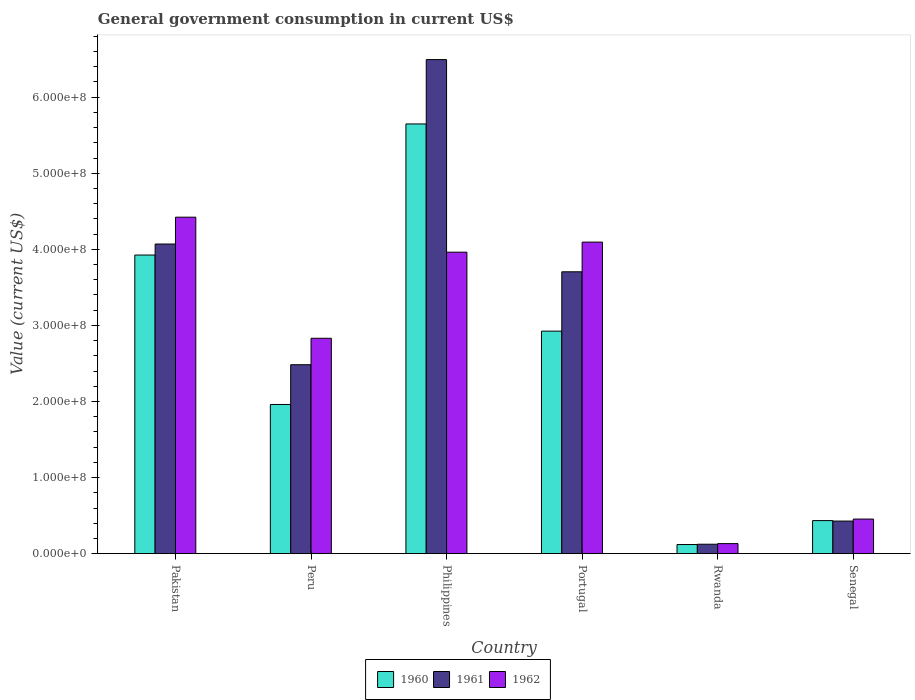How many different coloured bars are there?
Keep it short and to the point. 3. Are the number of bars per tick equal to the number of legend labels?
Offer a terse response. Yes. How many bars are there on the 6th tick from the left?
Provide a short and direct response. 3. How many bars are there on the 3rd tick from the right?
Ensure brevity in your answer.  3. What is the government conusmption in 1962 in Philippines?
Your response must be concise. 3.96e+08. Across all countries, what is the maximum government conusmption in 1962?
Your answer should be very brief. 4.42e+08. Across all countries, what is the minimum government conusmption in 1960?
Ensure brevity in your answer.  1.20e+07. In which country was the government conusmption in 1962 maximum?
Your answer should be very brief. Pakistan. In which country was the government conusmption in 1960 minimum?
Give a very brief answer. Rwanda. What is the total government conusmption in 1961 in the graph?
Your answer should be very brief. 1.73e+09. What is the difference between the government conusmption in 1962 in Pakistan and that in Senegal?
Give a very brief answer. 3.97e+08. What is the difference between the government conusmption in 1960 in Philippines and the government conusmption in 1961 in Portugal?
Keep it short and to the point. 1.94e+08. What is the average government conusmption in 1960 per country?
Your answer should be compact. 2.50e+08. What is the difference between the government conusmption of/in 1962 and government conusmption of/in 1960 in Philippines?
Offer a terse response. -1.69e+08. What is the ratio of the government conusmption in 1962 in Philippines to that in Portugal?
Your answer should be compact. 0.97. Is the government conusmption in 1962 in Portugal less than that in Rwanda?
Provide a succinct answer. No. Is the difference between the government conusmption in 1962 in Peru and Philippines greater than the difference between the government conusmption in 1960 in Peru and Philippines?
Your answer should be very brief. Yes. What is the difference between the highest and the second highest government conusmption in 1960?
Your answer should be very brief. 1.72e+08. What is the difference between the highest and the lowest government conusmption in 1961?
Offer a terse response. 6.37e+08. Is the sum of the government conusmption in 1960 in Pakistan and Peru greater than the maximum government conusmption in 1961 across all countries?
Give a very brief answer. No. How many bars are there?
Ensure brevity in your answer.  18. Are all the bars in the graph horizontal?
Give a very brief answer. No. What is the difference between two consecutive major ticks on the Y-axis?
Provide a short and direct response. 1.00e+08. Where does the legend appear in the graph?
Provide a succinct answer. Bottom center. How many legend labels are there?
Give a very brief answer. 3. What is the title of the graph?
Ensure brevity in your answer.  General government consumption in current US$. What is the label or title of the X-axis?
Provide a succinct answer. Country. What is the label or title of the Y-axis?
Give a very brief answer. Value (current US$). What is the Value (current US$) in 1960 in Pakistan?
Provide a succinct answer. 3.92e+08. What is the Value (current US$) in 1961 in Pakistan?
Provide a short and direct response. 4.07e+08. What is the Value (current US$) in 1962 in Pakistan?
Your answer should be very brief. 4.42e+08. What is the Value (current US$) in 1960 in Peru?
Ensure brevity in your answer.  1.96e+08. What is the Value (current US$) of 1961 in Peru?
Provide a short and direct response. 2.48e+08. What is the Value (current US$) in 1962 in Peru?
Your response must be concise. 2.83e+08. What is the Value (current US$) of 1960 in Philippines?
Ensure brevity in your answer.  5.65e+08. What is the Value (current US$) of 1961 in Philippines?
Your answer should be compact. 6.49e+08. What is the Value (current US$) of 1962 in Philippines?
Ensure brevity in your answer.  3.96e+08. What is the Value (current US$) in 1960 in Portugal?
Ensure brevity in your answer.  2.92e+08. What is the Value (current US$) of 1961 in Portugal?
Your answer should be compact. 3.70e+08. What is the Value (current US$) in 1962 in Portugal?
Your answer should be compact. 4.09e+08. What is the Value (current US$) of 1960 in Rwanda?
Give a very brief answer. 1.20e+07. What is the Value (current US$) of 1961 in Rwanda?
Your answer should be compact. 1.24e+07. What is the Value (current US$) in 1962 in Rwanda?
Keep it short and to the point. 1.32e+07. What is the Value (current US$) of 1960 in Senegal?
Ensure brevity in your answer.  4.35e+07. What is the Value (current US$) of 1961 in Senegal?
Provide a short and direct response. 4.28e+07. What is the Value (current US$) in 1962 in Senegal?
Provide a succinct answer. 4.55e+07. Across all countries, what is the maximum Value (current US$) in 1960?
Ensure brevity in your answer.  5.65e+08. Across all countries, what is the maximum Value (current US$) of 1961?
Offer a very short reply. 6.49e+08. Across all countries, what is the maximum Value (current US$) of 1962?
Keep it short and to the point. 4.42e+08. Across all countries, what is the minimum Value (current US$) in 1960?
Your answer should be compact. 1.20e+07. Across all countries, what is the minimum Value (current US$) of 1961?
Your response must be concise. 1.24e+07. Across all countries, what is the minimum Value (current US$) in 1962?
Ensure brevity in your answer.  1.32e+07. What is the total Value (current US$) in 1960 in the graph?
Offer a terse response. 1.50e+09. What is the total Value (current US$) of 1961 in the graph?
Provide a succinct answer. 1.73e+09. What is the total Value (current US$) of 1962 in the graph?
Your answer should be compact. 1.59e+09. What is the difference between the Value (current US$) of 1960 in Pakistan and that in Peru?
Your answer should be very brief. 1.96e+08. What is the difference between the Value (current US$) in 1961 in Pakistan and that in Peru?
Make the answer very short. 1.59e+08. What is the difference between the Value (current US$) in 1962 in Pakistan and that in Peru?
Provide a succinct answer. 1.59e+08. What is the difference between the Value (current US$) in 1960 in Pakistan and that in Philippines?
Provide a short and direct response. -1.72e+08. What is the difference between the Value (current US$) in 1961 in Pakistan and that in Philippines?
Ensure brevity in your answer.  -2.42e+08. What is the difference between the Value (current US$) of 1962 in Pakistan and that in Philippines?
Make the answer very short. 4.60e+07. What is the difference between the Value (current US$) in 1960 in Pakistan and that in Portugal?
Offer a very short reply. 1.00e+08. What is the difference between the Value (current US$) of 1961 in Pakistan and that in Portugal?
Give a very brief answer. 3.65e+07. What is the difference between the Value (current US$) in 1962 in Pakistan and that in Portugal?
Your response must be concise. 3.28e+07. What is the difference between the Value (current US$) of 1960 in Pakistan and that in Rwanda?
Provide a short and direct response. 3.80e+08. What is the difference between the Value (current US$) in 1961 in Pakistan and that in Rwanda?
Offer a very short reply. 3.95e+08. What is the difference between the Value (current US$) in 1962 in Pakistan and that in Rwanda?
Offer a terse response. 4.29e+08. What is the difference between the Value (current US$) of 1960 in Pakistan and that in Senegal?
Offer a terse response. 3.49e+08. What is the difference between the Value (current US$) of 1961 in Pakistan and that in Senegal?
Offer a very short reply. 3.64e+08. What is the difference between the Value (current US$) of 1962 in Pakistan and that in Senegal?
Give a very brief answer. 3.97e+08. What is the difference between the Value (current US$) in 1960 in Peru and that in Philippines?
Make the answer very short. -3.69e+08. What is the difference between the Value (current US$) of 1961 in Peru and that in Philippines?
Provide a short and direct response. -4.01e+08. What is the difference between the Value (current US$) of 1962 in Peru and that in Philippines?
Offer a very short reply. -1.13e+08. What is the difference between the Value (current US$) in 1960 in Peru and that in Portugal?
Provide a succinct answer. -9.64e+07. What is the difference between the Value (current US$) in 1961 in Peru and that in Portugal?
Your response must be concise. -1.22e+08. What is the difference between the Value (current US$) in 1962 in Peru and that in Portugal?
Your answer should be very brief. -1.26e+08. What is the difference between the Value (current US$) of 1960 in Peru and that in Rwanda?
Your response must be concise. 1.84e+08. What is the difference between the Value (current US$) of 1961 in Peru and that in Rwanda?
Provide a succinct answer. 2.36e+08. What is the difference between the Value (current US$) of 1962 in Peru and that in Rwanda?
Offer a very short reply. 2.70e+08. What is the difference between the Value (current US$) of 1960 in Peru and that in Senegal?
Provide a short and direct response. 1.53e+08. What is the difference between the Value (current US$) of 1961 in Peru and that in Senegal?
Make the answer very short. 2.05e+08. What is the difference between the Value (current US$) of 1962 in Peru and that in Senegal?
Offer a very short reply. 2.38e+08. What is the difference between the Value (current US$) of 1960 in Philippines and that in Portugal?
Make the answer very short. 2.72e+08. What is the difference between the Value (current US$) of 1961 in Philippines and that in Portugal?
Keep it short and to the point. 2.79e+08. What is the difference between the Value (current US$) of 1962 in Philippines and that in Portugal?
Offer a very short reply. -1.32e+07. What is the difference between the Value (current US$) in 1960 in Philippines and that in Rwanda?
Your answer should be compact. 5.53e+08. What is the difference between the Value (current US$) in 1961 in Philippines and that in Rwanda?
Give a very brief answer. 6.37e+08. What is the difference between the Value (current US$) in 1962 in Philippines and that in Rwanda?
Your answer should be compact. 3.83e+08. What is the difference between the Value (current US$) of 1960 in Philippines and that in Senegal?
Ensure brevity in your answer.  5.21e+08. What is the difference between the Value (current US$) of 1961 in Philippines and that in Senegal?
Your response must be concise. 6.07e+08. What is the difference between the Value (current US$) of 1962 in Philippines and that in Senegal?
Your answer should be compact. 3.51e+08. What is the difference between the Value (current US$) in 1960 in Portugal and that in Rwanda?
Your answer should be compact. 2.80e+08. What is the difference between the Value (current US$) in 1961 in Portugal and that in Rwanda?
Your response must be concise. 3.58e+08. What is the difference between the Value (current US$) of 1962 in Portugal and that in Rwanda?
Make the answer very short. 3.96e+08. What is the difference between the Value (current US$) in 1960 in Portugal and that in Senegal?
Offer a terse response. 2.49e+08. What is the difference between the Value (current US$) in 1961 in Portugal and that in Senegal?
Offer a terse response. 3.28e+08. What is the difference between the Value (current US$) of 1962 in Portugal and that in Senegal?
Your response must be concise. 3.64e+08. What is the difference between the Value (current US$) of 1960 in Rwanda and that in Senegal?
Provide a succinct answer. -3.15e+07. What is the difference between the Value (current US$) of 1961 in Rwanda and that in Senegal?
Keep it short and to the point. -3.04e+07. What is the difference between the Value (current US$) of 1962 in Rwanda and that in Senegal?
Ensure brevity in your answer.  -3.23e+07. What is the difference between the Value (current US$) of 1960 in Pakistan and the Value (current US$) of 1961 in Peru?
Offer a terse response. 1.44e+08. What is the difference between the Value (current US$) in 1960 in Pakistan and the Value (current US$) in 1962 in Peru?
Your answer should be compact. 1.09e+08. What is the difference between the Value (current US$) in 1961 in Pakistan and the Value (current US$) in 1962 in Peru?
Give a very brief answer. 1.24e+08. What is the difference between the Value (current US$) in 1960 in Pakistan and the Value (current US$) in 1961 in Philippines?
Provide a short and direct response. -2.57e+08. What is the difference between the Value (current US$) in 1960 in Pakistan and the Value (current US$) in 1962 in Philippines?
Provide a succinct answer. -3.77e+06. What is the difference between the Value (current US$) in 1961 in Pakistan and the Value (current US$) in 1962 in Philippines?
Offer a very short reply. 1.07e+07. What is the difference between the Value (current US$) in 1960 in Pakistan and the Value (current US$) in 1961 in Portugal?
Offer a very short reply. 2.20e+07. What is the difference between the Value (current US$) of 1960 in Pakistan and the Value (current US$) of 1962 in Portugal?
Provide a succinct answer. -1.70e+07. What is the difference between the Value (current US$) of 1961 in Pakistan and the Value (current US$) of 1962 in Portugal?
Keep it short and to the point. -2.49e+06. What is the difference between the Value (current US$) in 1960 in Pakistan and the Value (current US$) in 1961 in Rwanda?
Provide a succinct answer. 3.80e+08. What is the difference between the Value (current US$) of 1960 in Pakistan and the Value (current US$) of 1962 in Rwanda?
Your response must be concise. 3.79e+08. What is the difference between the Value (current US$) in 1961 in Pakistan and the Value (current US$) in 1962 in Rwanda?
Provide a short and direct response. 3.94e+08. What is the difference between the Value (current US$) in 1960 in Pakistan and the Value (current US$) in 1961 in Senegal?
Your answer should be very brief. 3.50e+08. What is the difference between the Value (current US$) of 1960 in Pakistan and the Value (current US$) of 1962 in Senegal?
Your response must be concise. 3.47e+08. What is the difference between the Value (current US$) in 1961 in Pakistan and the Value (current US$) in 1962 in Senegal?
Keep it short and to the point. 3.62e+08. What is the difference between the Value (current US$) of 1960 in Peru and the Value (current US$) of 1961 in Philippines?
Provide a short and direct response. -4.53e+08. What is the difference between the Value (current US$) in 1960 in Peru and the Value (current US$) in 1962 in Philippines?
Keep it short and to the point. -2.00e+08. What is the difference between the Value (current US$) in 1961 in Peru and the Value (current US$) in 1962 in Philippines?
Keep it short and to the point. -1.48e+08. What is the difference between the Value (current US$) in 1960 in Peru and the Value (current US$) in 1961 in Portugal?
Keep it short and to the point. -1.74e+08. What is the difference between the Value (current US$) in 1960 in Peru and the Value (current US$) in 1962 in Portugal?
Keep it short and to the point. -2.13e+08. What is the difference between the Value (current US$) in 1961 in Peru and the Value (current US$) in 1962 in Portugal?
Your answer should be very brief. -1.61e+08. What is the difference between the Value (current US$) of 1960 in Peru and the Value (current US$) of 1961 in Rwanda?
Give a very brief answer. 1.84e+08. What is the difference between the Value (current US$) in 1960 in Peru and the Value (current US$) in 1962 in Rwanda?
Provide a short and direct response. 1.83e+08. What is the difference between the Value (current US$) in 1961 in Peru and the Value (current US$) in 1962 in Rwanda?
Your answer should be very brief. 2.35e+08. What is the difference between the Value (current US$) in 1960 in Peru and the Value (current US$) in 1961 in Senegal?
Make the answer very short. 1.53e+08. What is the difference between the Value (current US$) of 1960 in Peru and the Value (current US$) of 1962 in Senegal?
Ensure brevity in your answer.  1.51e+08. What is the difference between the Value (current US$) of 1961 in Peru and the Value (current US$) of 1962 in Senegal?
Ensure brevity in your answer.  2.03e+08. What is the difference between the Value (current US$) of 1960 in Philippines and the Value (current US$) of 1961 in Portugal?
Give a very brief answer. 1.94e+08. What is the difference between the Value (current US$) of 1960 in Philippines and the Value (current US$) of 1962 in Portugal?
Your answer should be compact. 1.55e+08. What is the difference between the Value (current US$) in 1961 in Philippines and the Value (current US$) in 1962 in Portugal?
Give a very brief answer. 2.40e+08. What is the difference between the Value (current US$) of 1960 in Philippines and the Value (current US$) of 1961 in Rwanda?
Provide a succinct answer. 5.52e+08. What is the difference between the Value (current US$) of 1960 in Philippines and the Value (current US$) of 1962 in Rwanda?
Provide a short and direct response. 5.52e+08. What is the difference between the Value (current US$) in 1961 in Philippines and the Value (current US$) in 1962 in Rwanda?
Keep it short and to the point. 6.36e+08. What is the difference between the Value (current US$) of 1960 in Philippines and the Value (current US$) of 1961 in Senegal?
Make the answer very short. 5.22e+08. What is the difference between the Value (current US$) in 1960 in Philippines and the Value (current US$) in 1962 in Senegal?
Your answer should be compact. 5.19e+08. What is the difference between the Value (current US$) of 1961 in Philippines and the Value (current US$) of 1962 in Senegal?
Make the answer very short. 6.04e+08. What is the difference between the Value (current US$) of 1960 in Portugal and the Value (current US$) of 1961 in Rwanda?
Provide a succinct answer. 2.80e+08. What is the difference between the Value (current US$) of 1960 in Portugal and the Value (current US$) of 1962 in Rwanda?
Give a very brief answer. 2.79e+08. What is the difference between the Value (current US$) of 1961 in Portugal and the Value (current US$) of 1962 in Rwanda?
Make the answer very short. 3.57e+08. What is the difference between the Value (current US$) of 1960 in Portugal and the Value (current US$) of 1961 in Senegal?
Your answer should be compact. 2.50e+08. What is the difference between the Value (current US$) of 1960 in Portugal and the Value (current US$) of 1962 in Senegal?
Provide a short and direct response. 2.47e+08. What is the difference between the Value (current US$) in 1961 in Portugal and the Value (current US$) in 1962 in Senegal?
Provide a succinct answer. 3.25e+08. What is the difference between the Value (current US$) in 1960 in Rwanda and the Value (current US$) in 1961 in Senegal?
Your answer should be very brief. -3.08e+07. What is the difference between the Value (current US$) of 1960 in Rwanda and the Value (current US$) of 1962 in Senegal?
Your answer should be very brief. -3.35e+07. What is the difference between the Value (current US$) in 1961 in Rwanda and the Value (current US$) in 1962 in Senegal?
Offer a terse response. -3.31e+07. What is the average Value (current US$) in 1960 per country?
Your response must be concise. 2.50e+08. What is the average Value (current US$) in 1961 per country?
Your answer should be very brief. 2.88e+08. What is the average Value (current US$) of 1962 per country?
Provide a short and direct response. 2.65e+08. What is the difference between the Value (current US$) of 1960 and Value (current US$) of 1961 in Pakistan?
Provide a short and direct response. -1.45e+07. What is the difference between the Value (current US$) in 1960 and Value (current US$) in 1962 in Pakistan?
Give a very brief answer. -4.98e+07. What is the difference between the Value (current US$) in 1961 and Value (current US$) in 1962 in Pakistan?
Offer a terse response. -3.53e+07. What is the difference between the Value (current US$) in 1960 and Value (current US$) in 1961 in Peru?
Provide a short and direct response. -5.22e+07. What is the difference between the Value (current US$) of 1960 and Value (current US$) of 1962 in Peru?
Your answer should be compact. -8.70e+07. What is the difference between the Value (current US$) in 1961 and Value (current US$) in 1962 in Peru?
Provide a short and direct response. -3.48e+07. What is the difference between the Value (current US$) in 1960 and Value (current US$) in 1961 in Philippines?
Give a very brief answer. -8.46e+07. What is the difference between the Value (current US$) of 1960 and Value (current US$) of 1962 in Philippines?
Your response must be concise. 1.69e+08. What is the difference between the Value (current US$) in 1961 and Value (current US$) in 1962 in Philippines?
Offer a very short reply. 2.53e+08. What is the difference between the Value (current US$) in 1960 and Value (current US$) in 1961 in Portugal?
Offer a terse response. -7.80e+07. What is the difference between the Value (current US$) in 1960 and Value (current US$) in 1962 in Portugal?
Offer a very short reply. -1.17e+08. What is the difference between the Value (current US$) in 1961 and Value (current US$) in 1962 in Portugal?
Keep it short and to the point. -3.90e+07. What is the difference between the Value (current US$) of 1960 and Value (current US$) of 1961 in Rwanda?
Keep it short and to the point. -4.00e+05. What is the difference between the Value (current US$) in 1960 and Value (current US$) in 1962 in Rwanda?
Offer a terse response. -1.20e+06. What is the difference between the Value (current US$) in 1961 and Value (current US$) in 1962 in Rwanda?
Your answer should be very brief. -8.00e+05. What is the difference between the Value (current US$) of 1960 and Value (current US$) of 1961 in Senegal?
Your response must be concise. 6.19e+05. What is the difference between the Value (current US$) in 1960 and Value (current US$) in 1962 in Senegal?
Keep it short and to the point. -2.01e+06. What is the difference between the Value (current US$) of 1961 and Value (current US$) of 1962 in Senegal?
Provide a short and direct response. -2.63e+06. What is the ratio of the Value (current US$) in 1960 in Pakistan to that in Peru?
Offer a terse response. 2. What is the ratio of the Value (current US$) in 1961 in Pakistan to that in Peru?
Give a very brief answer. 1.64. What is the ratio of the Value (current US$) in 1962 in Pakistan to that in Peru?
Your response must be concise. 1.56. What is the ratio of the Value (current US$) of 1960 in Pakistan to that in Philippines?
Offer a very short reply. 0.69. What is the ratio of the Value (current US$) of 1961 in Pakistan to that in Philippines?
Give a very brief answer. 0.63. What is the ratio of the Value (current US$) in 1962 in Pakistan to that in Philippines?
Offer a very short reply. 1.12. What is the ratio of the Value (current US$) in 1960 in Pakistan to that in Portugal?
Offer a terse response. 1.34. What is the ratio of the Value (current US$) in 1961 in Pakistan to that in Portugal?
Offer a terse response. 1.1. What is the ratio of the Value (current US$) in 1962 in Pakistan to that in Portugal?
Provide a succinct answer. 1.08. What is the ratio of the Value (current US$) of 1960 in Pakistan to that in Rwanda?
Your answer should be compact. 32.71. What is the ratio of the Value (current US$) in 1961 in Pakistan to that in Rwanda?
Ensure brevity in your answer.  32.82. What is the ratio of the Value (current US$) in 1962 in Pakistan to that in Rwanda?
Offer a very short reply. 33.5. What is the ratio of the Value (current US$) in 1960 in Pakistan to that in Senegal?
Provide a short and direct response. 9.03. What is the ratio of the Value (current US$) of 1961 in Pakistan to that in Senegal?
Your answer should be compact. 9.5. What is the ratio of the Value (current US$) of 1962 in Pakistan to that in Senegal?
Give a very brief answer. 9.73. What is the ratio of the Value (current US$) of 1960 in Peru to that in Philippines?
Your answer should be compact. 0.35. What is the ratio of the Value (current US$) in 1961 in Peru to that in Philippines?
Keep it short and to the point. 0.38. What is the ratio of the Value (current US$) of 1962 in Peru to that in Philippines?
Provide a short and direct response. 0.71. What is the ratio of the Value (current US$) of 1960 in Peru to that in Portugal?
Keep it short and to the point. 0.67. What is the ratio of the Value (current US$) of 1961 in Peru to that in Portugal?
Provide a succinct answer. 0.67. What is the ratio of the Value (current US$) of 1962 in Peru to that in Portugal?
Ensure brevity in your answer.  0.69. What is the ratio of the Value (current US$) in 1960 in Peru to that in Rwanda?
Offer a terse response. 16.34. What is the ratio of the Value (current US$) of 1961 in Peru to that in Rwanda?
Your answer should be compact. 20.03. What is the ratio of the Value (current US$) in 1962 in Peru to that in Rwanda?
Make the answer very short. 21.45. What is the ratio of the Value (current US$) of 1960 in Peru to that in Senegal?
Offer a terse response. 4.51. What is the ratio of the Value (current US$) of 1961 in Peru to that in Senegal?
Give a very brief answer. 5.8. What is the ratio of the Value (current US$) in 1962 in Peru to that in Senegal?
Your response must be concise. 6.23. What is the ratio of the Value (current US$) of 1960 in Philippines to that in Portugal?
Provide a succinct answer. 1.93. What is the ratio of the Value (current US$) in 1961 in Philippines to that in Portugal?
Provide a succinct answer. 1.75. What is the ratio of the Value (current US$) of 1960 in Philippines to that in Rwanda?
Provide a short and direct response. 47.07. What is the ratio of the Value (current US$) in 1961 in Philippines to that in Rwanda?
Give a very brief answer. 52.37. What is the ratio of the Value (current US$) in 1962 in Philippines to that in Rwanda?
Give a very brief answer. 30.02. What is the ratio of the Value (current US$) of 1960 in Philippines to that in Senegal?
Ensure brevity in your answer.  13. What is the ratio of the Value (current US$) of 1961 in Philippines to that in Senegal?
Ensure brevity in your answer.  15.16. What is the ratio of the Value (current US$) in 1962 in Philippines to that in Senegal?
Make the answer very short. 8.72. What is the ratio of the Value (current US$) of 1960 in Portugal to that in Rwanda?
Keep it short and to the point. 24.37. What is the ratio of the Value (current US$) of 1961 in Portugal to that in Rwanda?
Offer a very short reply. 29.88. What is the ratio of the Value (current US$) of 1962 in Portugal to that in Rwanda?
Offer a terse response. 31.02. What is the ratio of the Value (current US$) in 1960 in Portugal to that in Senegal?
Offer a very short reply. 6.73. What is the ratio of the Value (current US$) in 1961 in Portugal to that in Senegal?
Keep it short and to the point. 8.65. What is the ratio of the Value (current US$) of 1962 in Portugal to that in Senegal?
Ensure brevity in your answer.  9.01. What is the ratio of the Value (current US$) in 1960 in Rwanda to that in Senegal?
Give a very brief answer. 0.28. What is the ratio of the Value (current US$) of 1961 in Rwanda to that in Senegal?
Provide a short and direct response. 0.29. What is the ratio of the Value (current US$) of 1962 in Rwanda to that in Senegal?
Provide a short and direct response. 0.29. What is the difference between the highest and the second highest Value (current US$) in 1960?
Provide a succinct answer. 1.72e+08. What is the difference between the highest and the second highest Value (current US$) in 1961?
Give a very brief answer. 2.42e+08. What is the difference between the highest and the second highest Value (current US$) of 1962?
Your response must be concise. 3.28e+07. What is the difference between the highest and the lowest Value (current US$) in 1960?
Your answer should be very brief. 5.53e+08. What is the difference between the highest and the lowest Value (current US$) in 1961?
Give a very brief answer. 6.37e+08. What is the difference between the highest and the lowest Value (current US$) in 1962?
Give a very brief answer. 4.29e+08. 